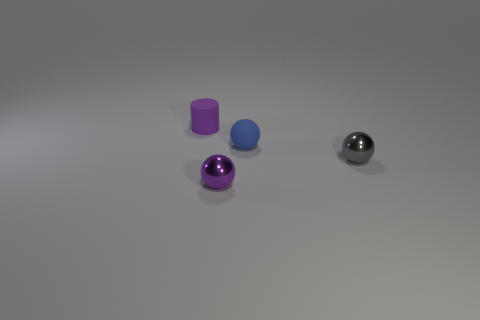Are the purple thing behind the small purple metal thing and the gray object made of the same material?
Your answer should be very brief. No. There is a cylinder that is the same size as the purple metal object; what is it made of?
Your answer should be compact. Rubber. What number of other objects are the same material as the purple sphere?
Keep it short and to the point. 1. There is a purple sphere; does it have the same size as the matte object that is on the left side of the blue rubber thing?
Your answer should be very brief. Yes. Are there fewer blue objects that are behind the small matte ball than purple metal objects that are left of the purple metallic thing?
Ensure brevity in your answer.  No. There is a purple object that is in front of the small purple matte cylinder; what is its size?
Offer a terse response. Small. Do the gray metallic sphere and the blue object have the same size?
Give a very brief answer. Yes. How many spheres are both behind the tiny gray thing and in front of the tiny gray thing?
Keep it short and to the point. 0. What number of purple objects are either tiny balls or shiny things?
Offer a terse response. 1. What number of shiny things are gray things or tiny purple objects?
Ensure brevity in your answer.  2. 